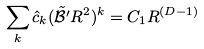<formula> <loc_0><loc_0><loc_500><loc_500>\sum _ { k } \hat { c } _ { k } ( \tilde { \mathcal { B } ^ { \prime } } R ^ { 2 } ) ^ { k } = C _ { 1 } R ^ { ( D - 1 ) }</formula> 